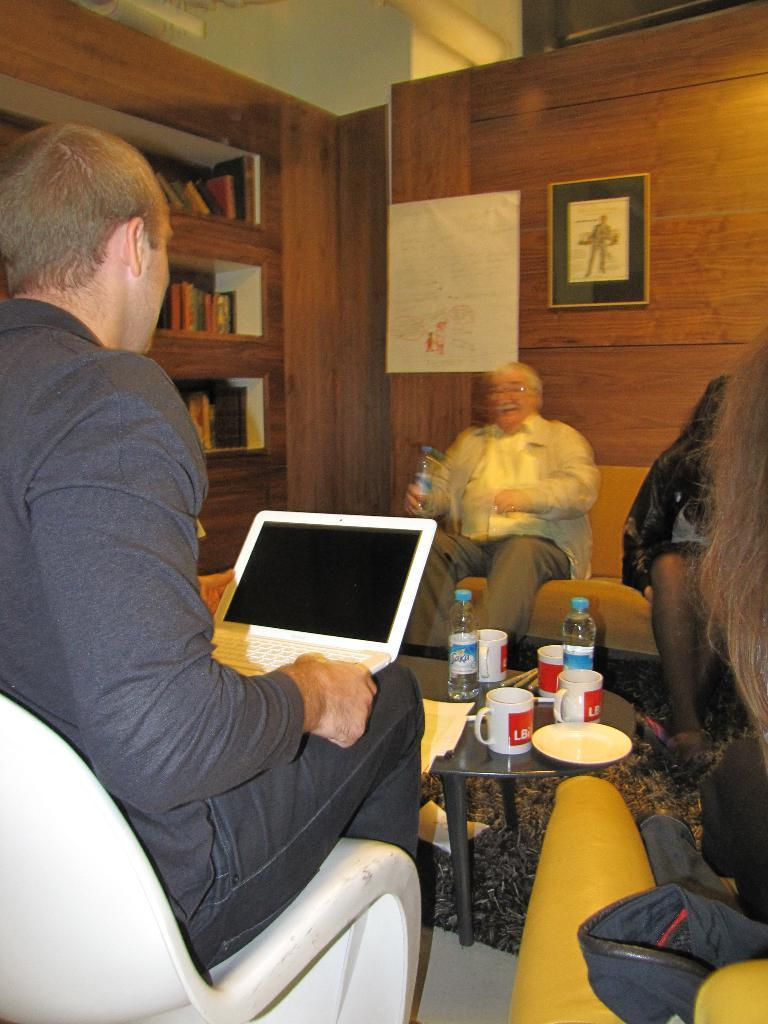What object can be seen in the image that is typically used for displaying photos? There is a photo frame in the image. What type of furniture can be seen in the image that people might sit on? There are people sitting on sofas in the image. What piece of furniture is present in the image that is often used for placing objects? There is a table in the image. What items can be seen on the table in the image? There are bottles, a plate, and cups on the table. Can you tell me how many yaks are grazing in the park in the image? There are no yaks or parks present in the image; it features a photo frame, sofas, a table, and objects on the table. 